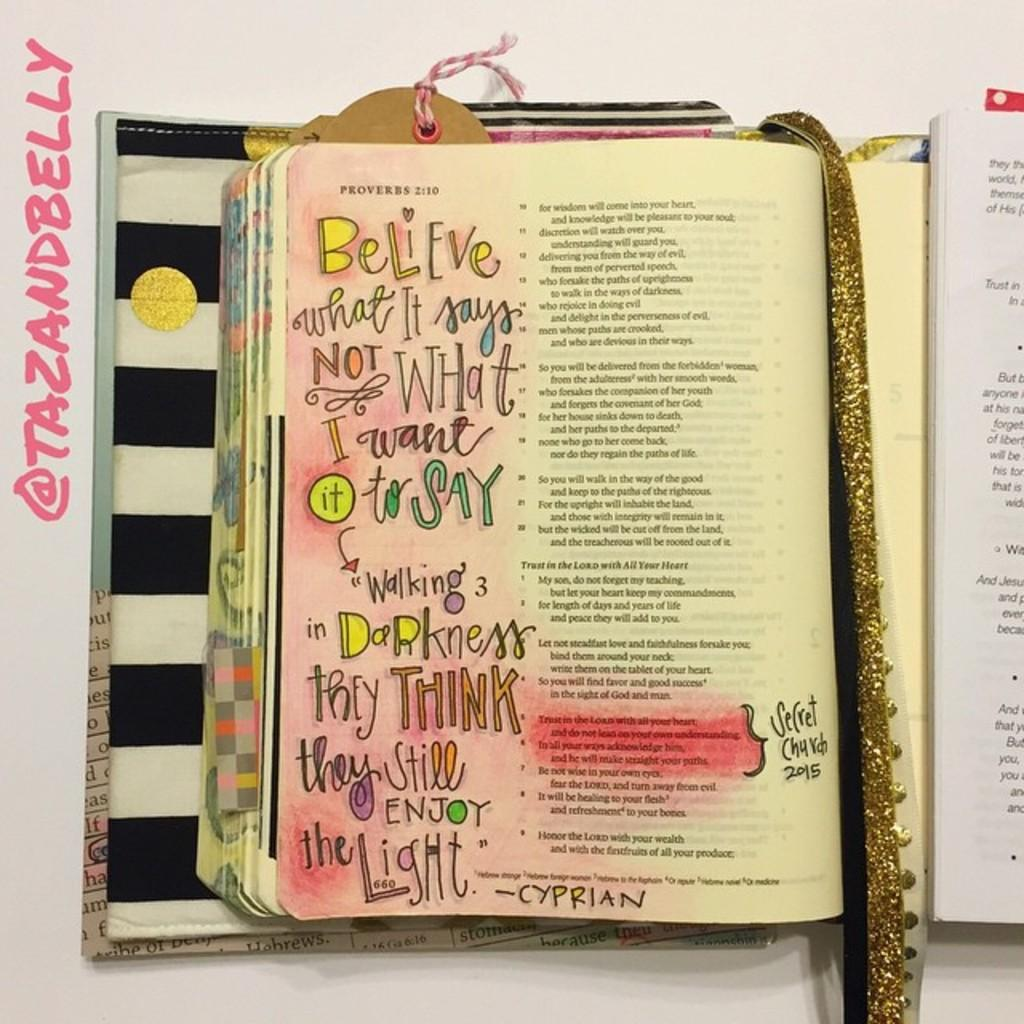<image>
Share a concise interpretation of the image provided. A page out of the bible with handwritten notes on the page 